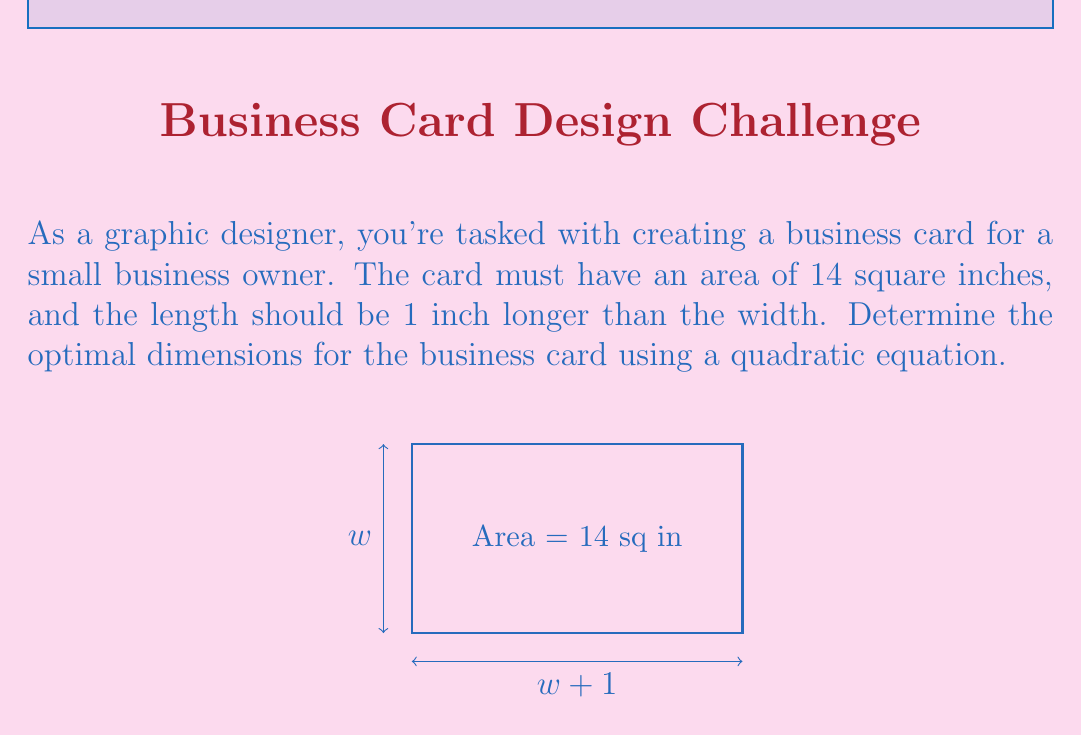Help me with this question. Let's solve this step-by-step:

1) Let $w$ be the width of the card. Then the length is $w + 1$.

2) The area of a rectangle is length times width. So we can set up the equation:
   $$ w(w + 1) = 14 $$

3) Expand this equation:
   $$ w^2 + w = 14 $$

4) Rearrange to standard form of a quadratic equation:
   $$ w^2 + w - 14 = 0 $$

5) We can solve this using the quadratic formula: $x = \frac{-b \pm \sqrt{b^2 - 4ac}}{2a}$
   Where $a = 1$, $b = 1$, and $c = -14$

6) Plugging into the formula:
   $$ w = \frac{-1 \pm \sqrt{1^2 - 4(1)(-14)}}{2(1)} = \frac{-1 \pm \sqrt{57}}{2} $$

7) Simplify:
   $$ w = \frac{-1 \pm 7.55}{2} $$

8) This gives us two solutions:
   $$ w = \frac{-1 + 7.55}{2} = 3.275 \text{ or } w = \frac{-1 - 7.55}{2} = -4.275 $$

9) Since width can't be negative, we take the positive solution: $w = 3.275$ inches

10) The length is $w + 1 = 4.275$ inches
Answer: Width: 3.275 inches, Length: 4.275 inches 